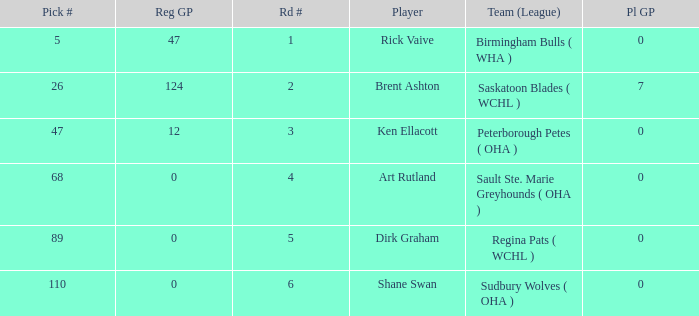How many reg GP for rick vaive in round 1? None. 